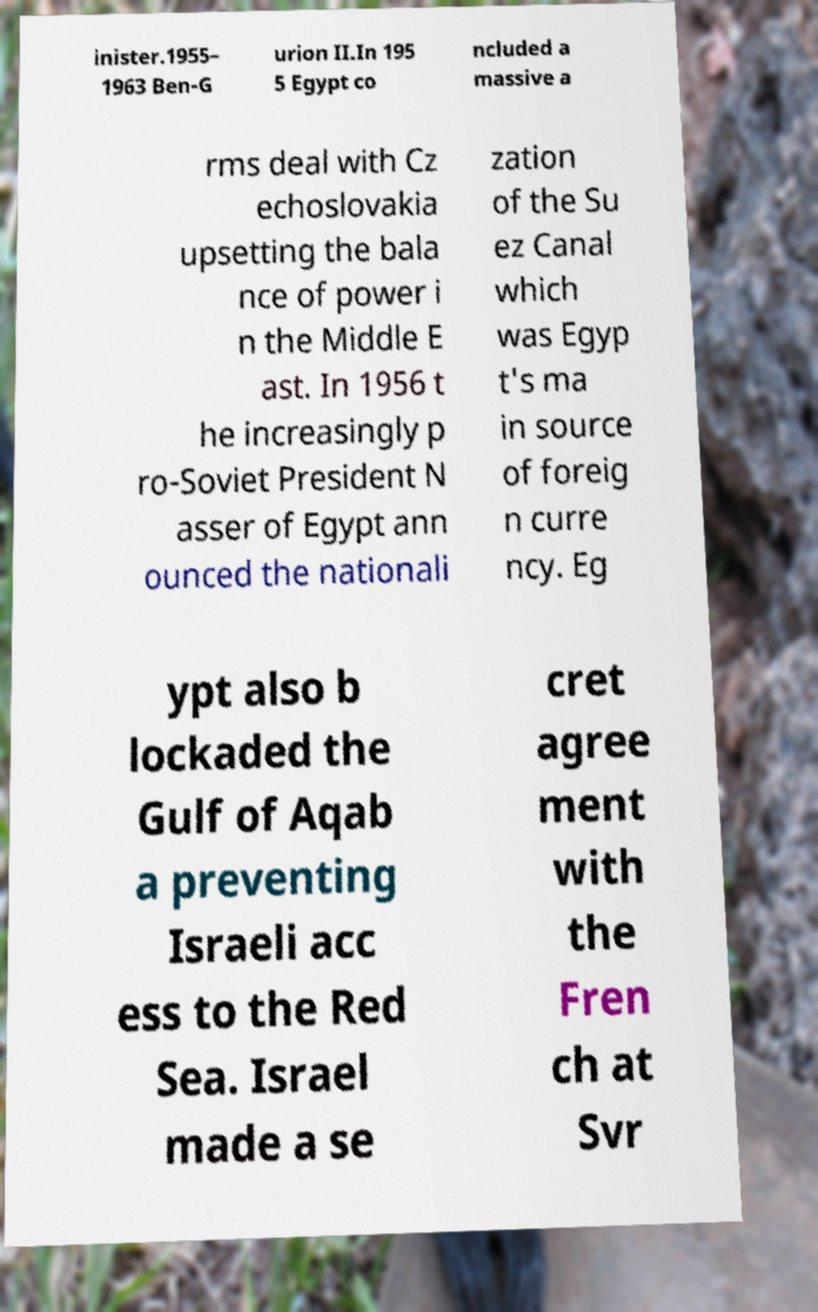Could you extract and type out the text from this image? inister.1955– 1963 Ben-G urion II.In 195 5 Egypt co ncluded a massive a rms deal with Cz echoslovakia upsetting the bala nce of power i n the Middle E ast. In 1956 t he increasingly p ro-Soviet President N asser of Egypt ann ounced the nationali zation of the Su ez Canal which was Egyp t's ma in source of foreig n curre ncy. Eg ypt also b lockaded the Gulf of Aqab a preventing Israeli acc ess to the Red Sea. Israel made a se cret agree ment with the Fren ch at Svr 